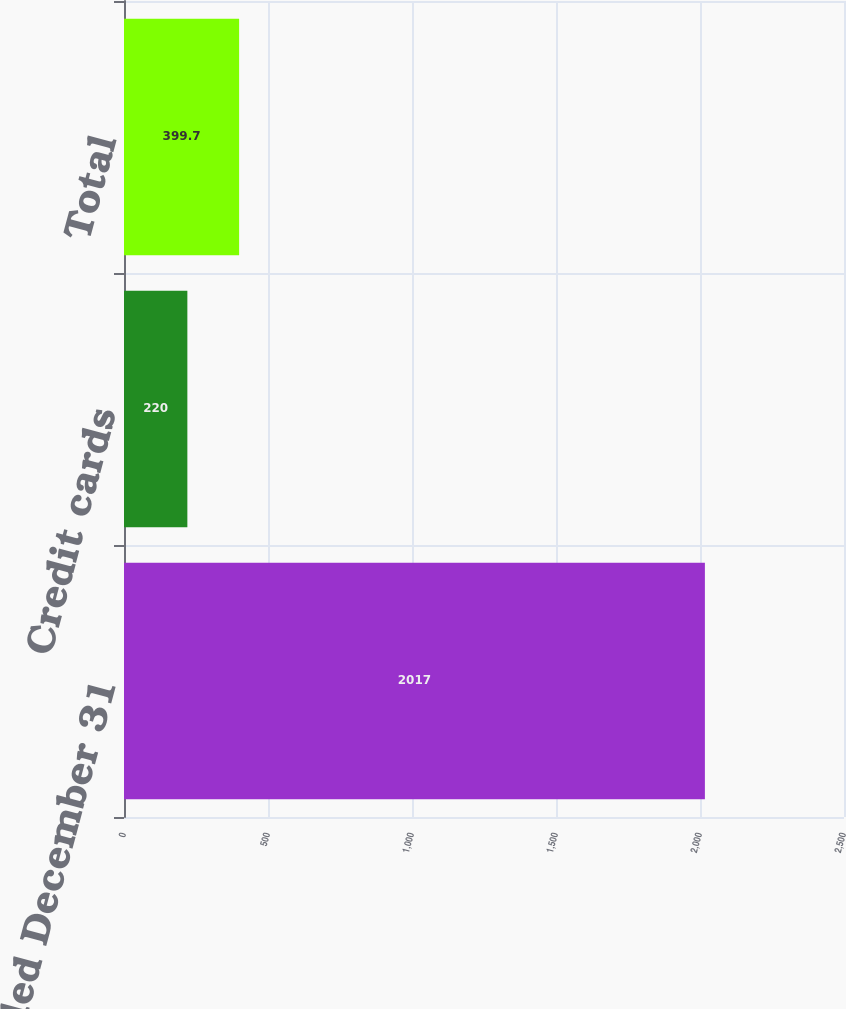Convert chart. <chart><loc_0><loc_0><loc_500><loc_500><bar_chart><fcel>Years ended December 31<fcel>Credit cards<fcel>Total<nl><fcel>2017<fcel>220<fcel>399.7<nl></chart> 